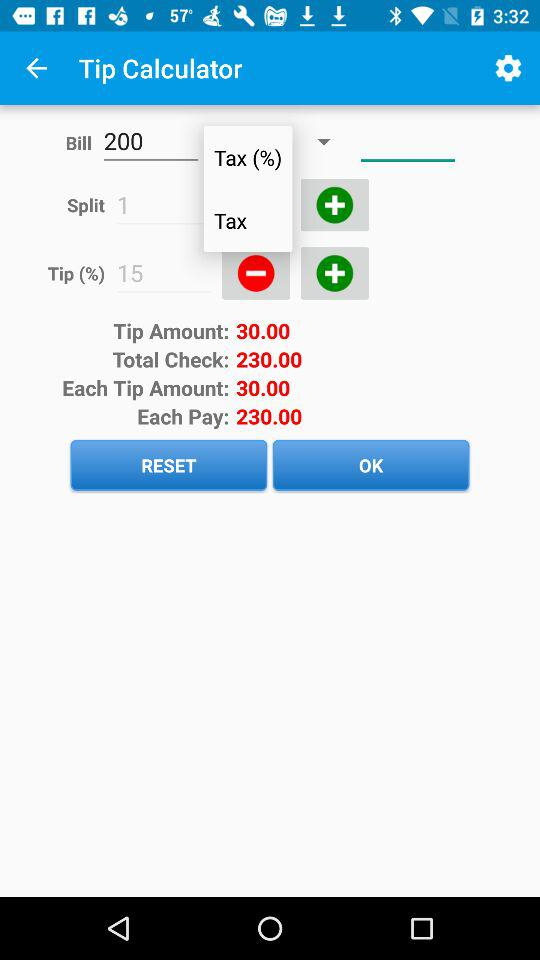What is the total check amount? The total check amount is 230.00. 